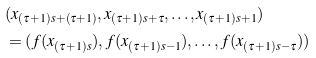Convert formula to latex. <formula><loc_0><loc_0><loc_500><loc_500>& ( x _ { ( \tau + 1 ) s + ( \tau + 1 ) } , x _ { ( \tau + 1 ) s + \tau } , \dots , x _ { ( \tau + 1 ) s + 1 } ) \\ & = ( f ( x _ { ( \tau + 1 ) s } ) , f ( x _ { ( \tau + 1 ) s - 1 } ) , \dots , f ( x _ { ( \tau + 1 ) s - \tau } ) )</formula> 